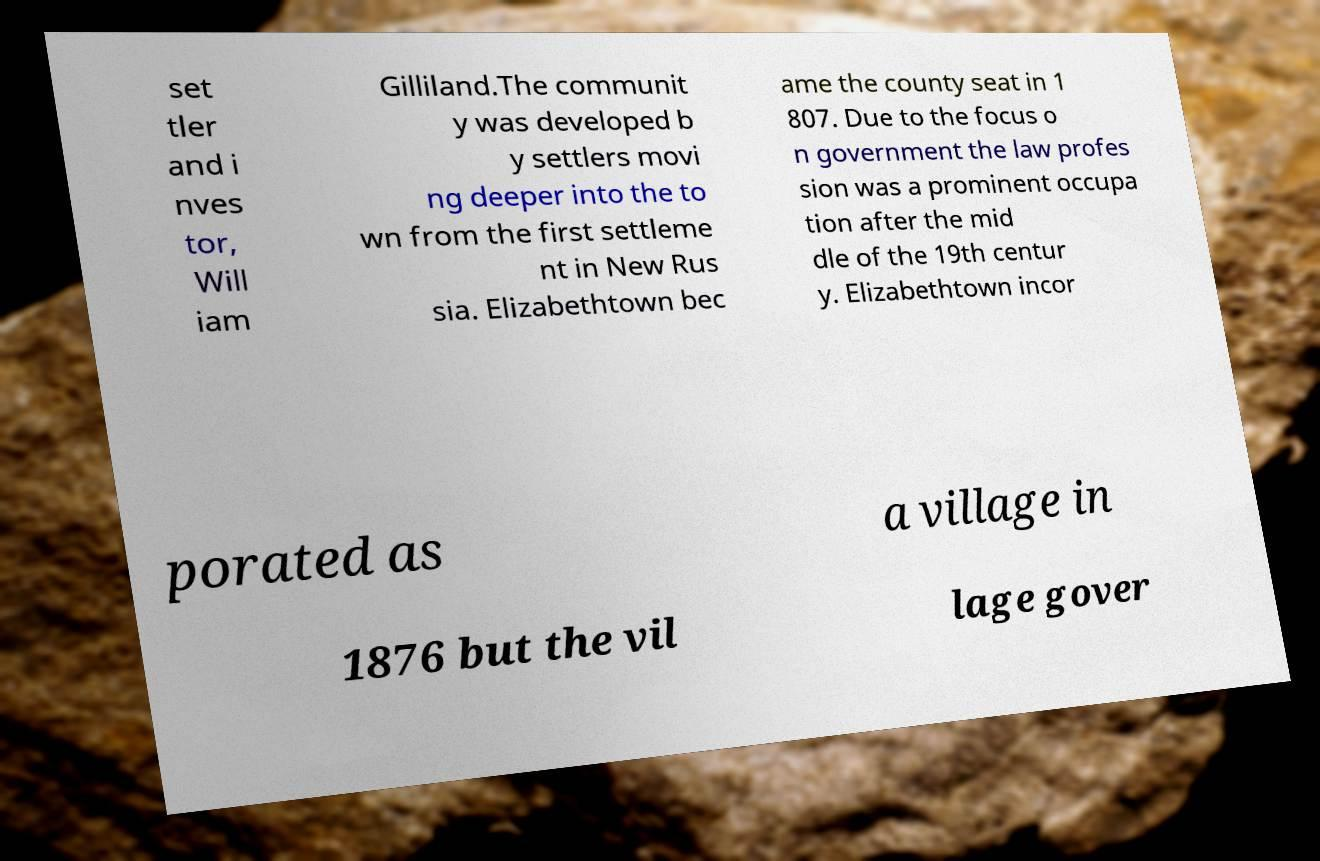Please read and relay the text visible in this image. What does it say? set tler and i nves tor, Will iam Gilliland.The communit y was developed b y settlers movi ng deeper into the to wn from the first settleme nt in New Rus sia. Elizabethtown bec ame the county seat in 1 807. Due to the focus o n government the law profes sion was a prominent occupa tion after the mid dle of the 19th centur y. Elizabethtown incor porated as a village in 1876 but the vil lage gover 